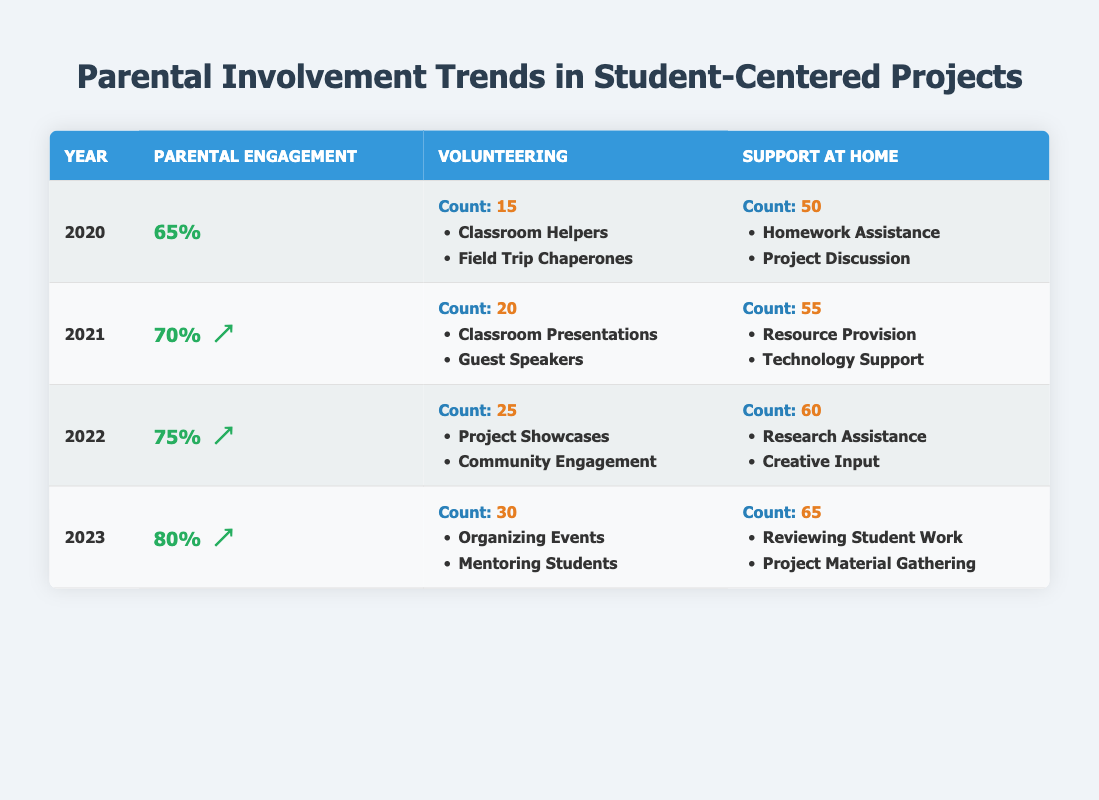What was the parental engagement percentage in 2021? The table lists the parental engagement percentage for each year. In the row for 2021, the percentage is shown as 70%.
Answer: 70% How many volunteer activities were recorded in 2022? The table indicates that in 2022, the count of volunteering activities is 25.
Answer: 25 Was the parental engagement percentage higher in 2023 than in 2020? In 2023, the parental engagement percentage was 80%, and in 2020, it was 65%. Since 80 is greater than 65, the statement is true.
Answer: Yes What types of at-home support increased from 2021 to 2023? In 2021, the count for support at home was 55, and it increased to 65 in 2023. The types listed for 2021 include Resource Provision and Technology Support, while in 2023, they are Reviewing Student Work and Project Material Gathering. Since both the count and the types changed, we see an increase.
Answer: Support at home increased What was the total count of volunteer activities across all years? The counts of volunteering activities are 15, 20, 25, and 30 for the years 2020 to 2023 respectively. Summing them gives: 15 + 20 + 25 + 30 = 90.
Answer: 90 In which year did parental engagement show the greatest increase compared to the previous year? By calculating the differences: from 2020 to 2021 it increased by 5%, from 2021 to 2022 it increased by 5%, and from 2022 to 2023 it increased by 5%. All increases are equal, so there is no single year with a greater increase.
Answer: No single year had the greatest increase Did the examples of volunteering remain the same from 2020 to 2023? The examples of volunteering in 2020 were Classroom Helpers and Field Trip Chaperones. In 2023, they changed to Organizing Events and Mentoring Students, showing that the examples did not remain the same.
Answer: No What percentage increase in parental engagement was observed from 2020 to 2023? The parental engagement increased from 65% in 2020 to 80% in 2023. The percentage increase is calculated as ((80 - 65) / 65) * 100 = 23.08%.
Answer: 23.08% 